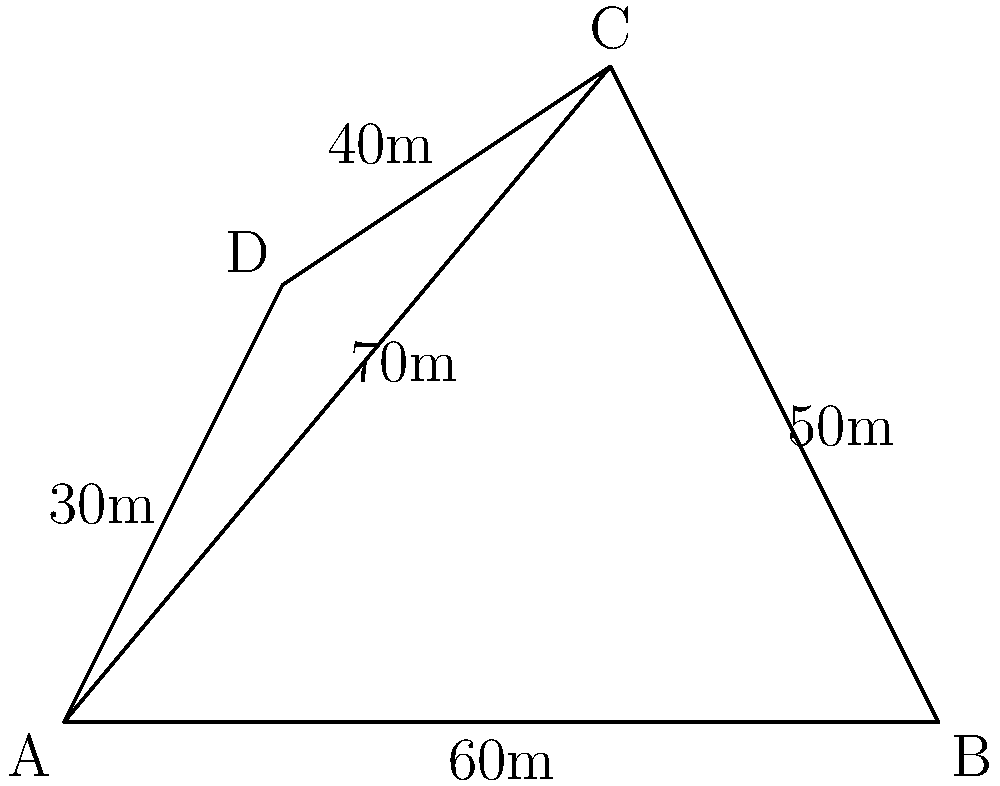As a wine blogger, you've been asked to estimate the area of an irregularly shaped vineyard plot. The plot is represented by the quadrilateral ABCD in the diagram. Given the measurements of the sides and one diagonal (AC), calculate the total area of the vineyard plot in square meters. To calculate the area of the irregular vineyard plot, we can use the triangulation method. We'll divide the quadrilateral into two triangles and calculate their areas separately.

Step 1: Divide the quadrilateral into triangles ABC and ACD.

Step 2: Calculate the area of triangle ABC using Heron's formula.
Heron's formula: $A = \sqrt{s(s-a)(s-b)(s-c)}$, where $s = \frac{a+b+c}{2}$ (semi-perimeter)

For triangle ABC:
$a = 60$ m, $b = 50$ m, $c = 70$ m
$s = \frac{60 + 50 + 70}{2} = 90$ m
$A_{ABC} = \sqrt{90(90-60)(90-50)(90-70)} = \sqrt{90 \cdot 30 \cdot 40 \cdot 20} = 600$ m²

Step 3: Calculate the area of triangle ACD using the same method.
For triangle ACD:
$a = 70$ m, $b = 40$ m, $c = 30$ m
$s = \frac{70 + 40 + 30}{2} = 70$ m
$A_{ACD} = \sqrt{70(70-70)(70-40)(70-30)} = \sqrt{70 \cdot 0 \cdot 30 \cdot 40} = 0$ m²

Step 4: Sum the areas of both triangles.
Total Area = $A_{ABC} + A_{ACD} = 600 + 0 = 600$ m²
Answer: 600 m² 